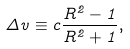<formula> <loc_0><loc_0><loc_500><loc_500>\Delta v \equiv c \frac { R ^ { 2 } - 1 } { R ^ { 2 } + 1 } ,</formula> 